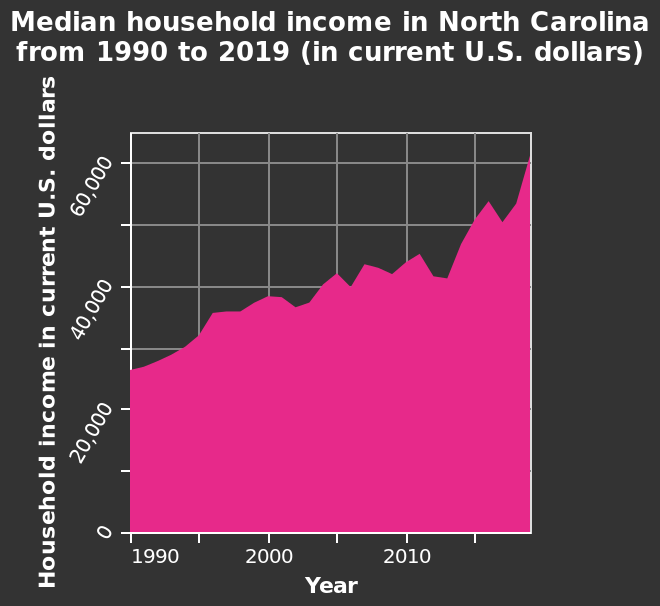<image>
What is the range of the y-axis on the area chart for household income?  The y-axis on the area chart ranges from 0 to 60,000, representing household income in current U.S. dollars. What is the current median income in North Carolina? The current median income in North Carolina is $60,000. What is the scale used on the x-axis of the area chart? The x-axis of the area chart uses a linear scale from 1990 to 2015. Is the growth of median income in North Carolina linear or exponential?  The growth of median income in North Carolina is exponential. What was the median income in North Carolina in 1990?  The median income in North Carolina in 1990 was approximately $30,000. 